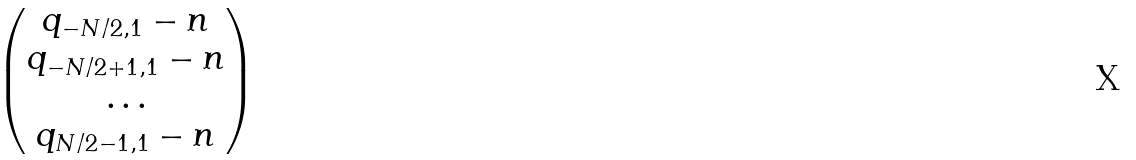<formula> <loc_0><loc_0><loc_500><loc_500>\begin{pmatrix} q _ { - N / 2 , 1 } - n \\ q _ { - N / 2 + 1 , 1 } - n \\ \dots \\ q _ { N / 2 - 1 , 1 } - n \end{pmatrix}</formula> 